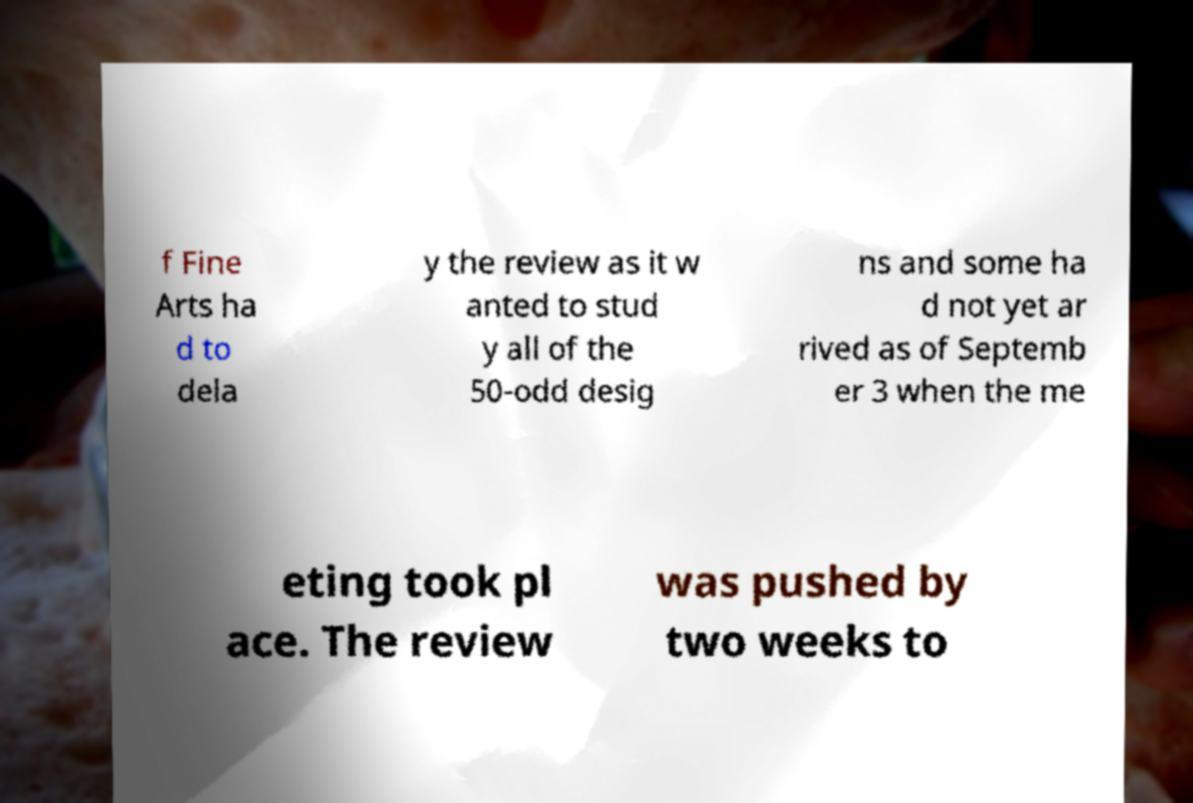What messages or text are displayed in this image? I need them in a readable, typed format. f Fine Arts ha d to dela y the review as it w anted to stud y all of the 50-odd desig ns and some ha d not yet ar rived as of Septemb er 3 when the me eting took pl ace. The review was pushed by two weeks to 